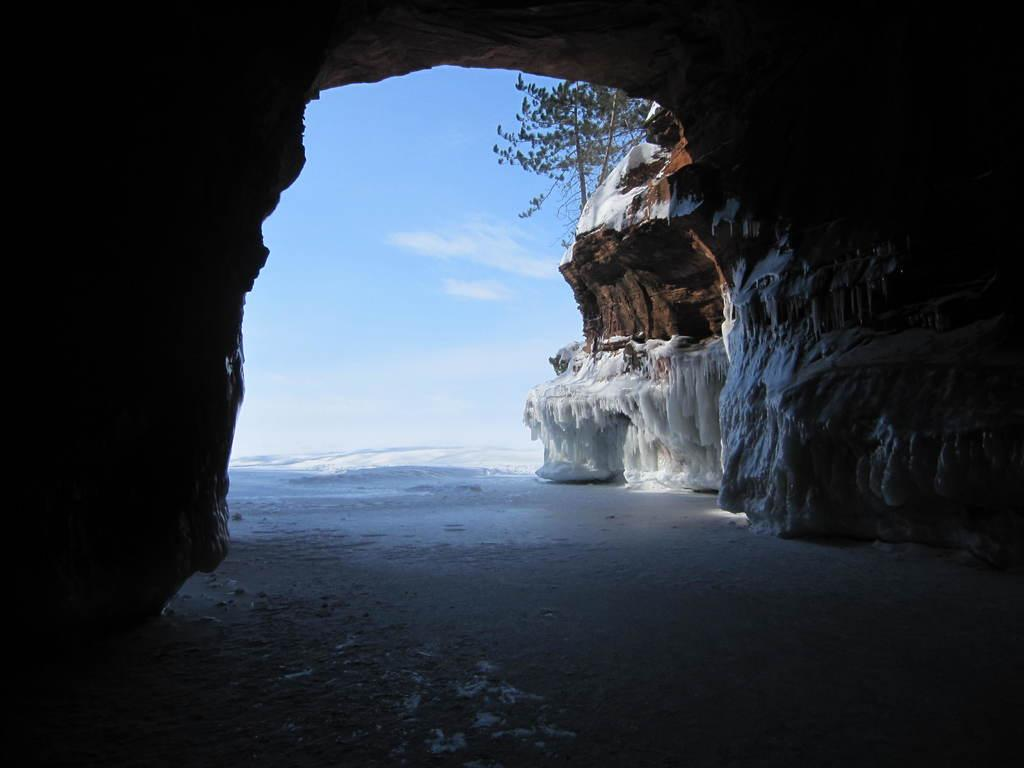What type of natural formation is present in the image? There is a cave in the image. What is the texture of the ice in the image? The ice is present in the image. What type of plant can be seen in the image? There is a tree in the image. What is visible in the background of the image? The sky is visible in the background of the image. How would you describe the weather based on the sky in the image? The sky appears to be cloudy in the image. Can you see the rabbit writing a letter in the cave? There is no rabbit or writing activity present in the image. What color is the writer's hair in the image? There is no writer or hair present in the image. 